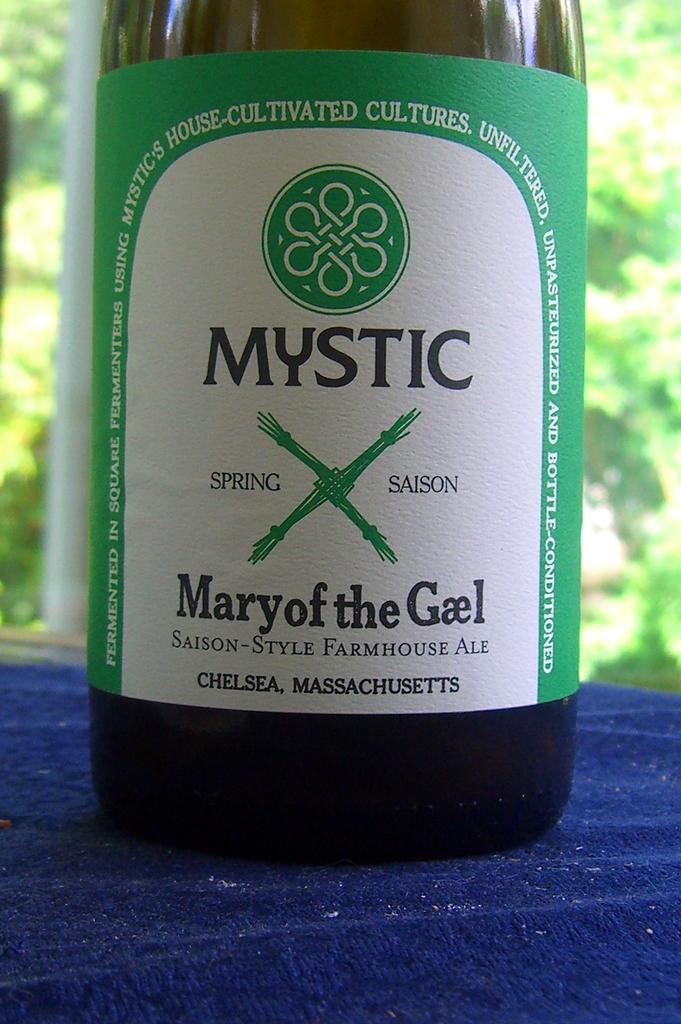What is the name of the beverage?
Offer a very short reply. Mary of the gael. 